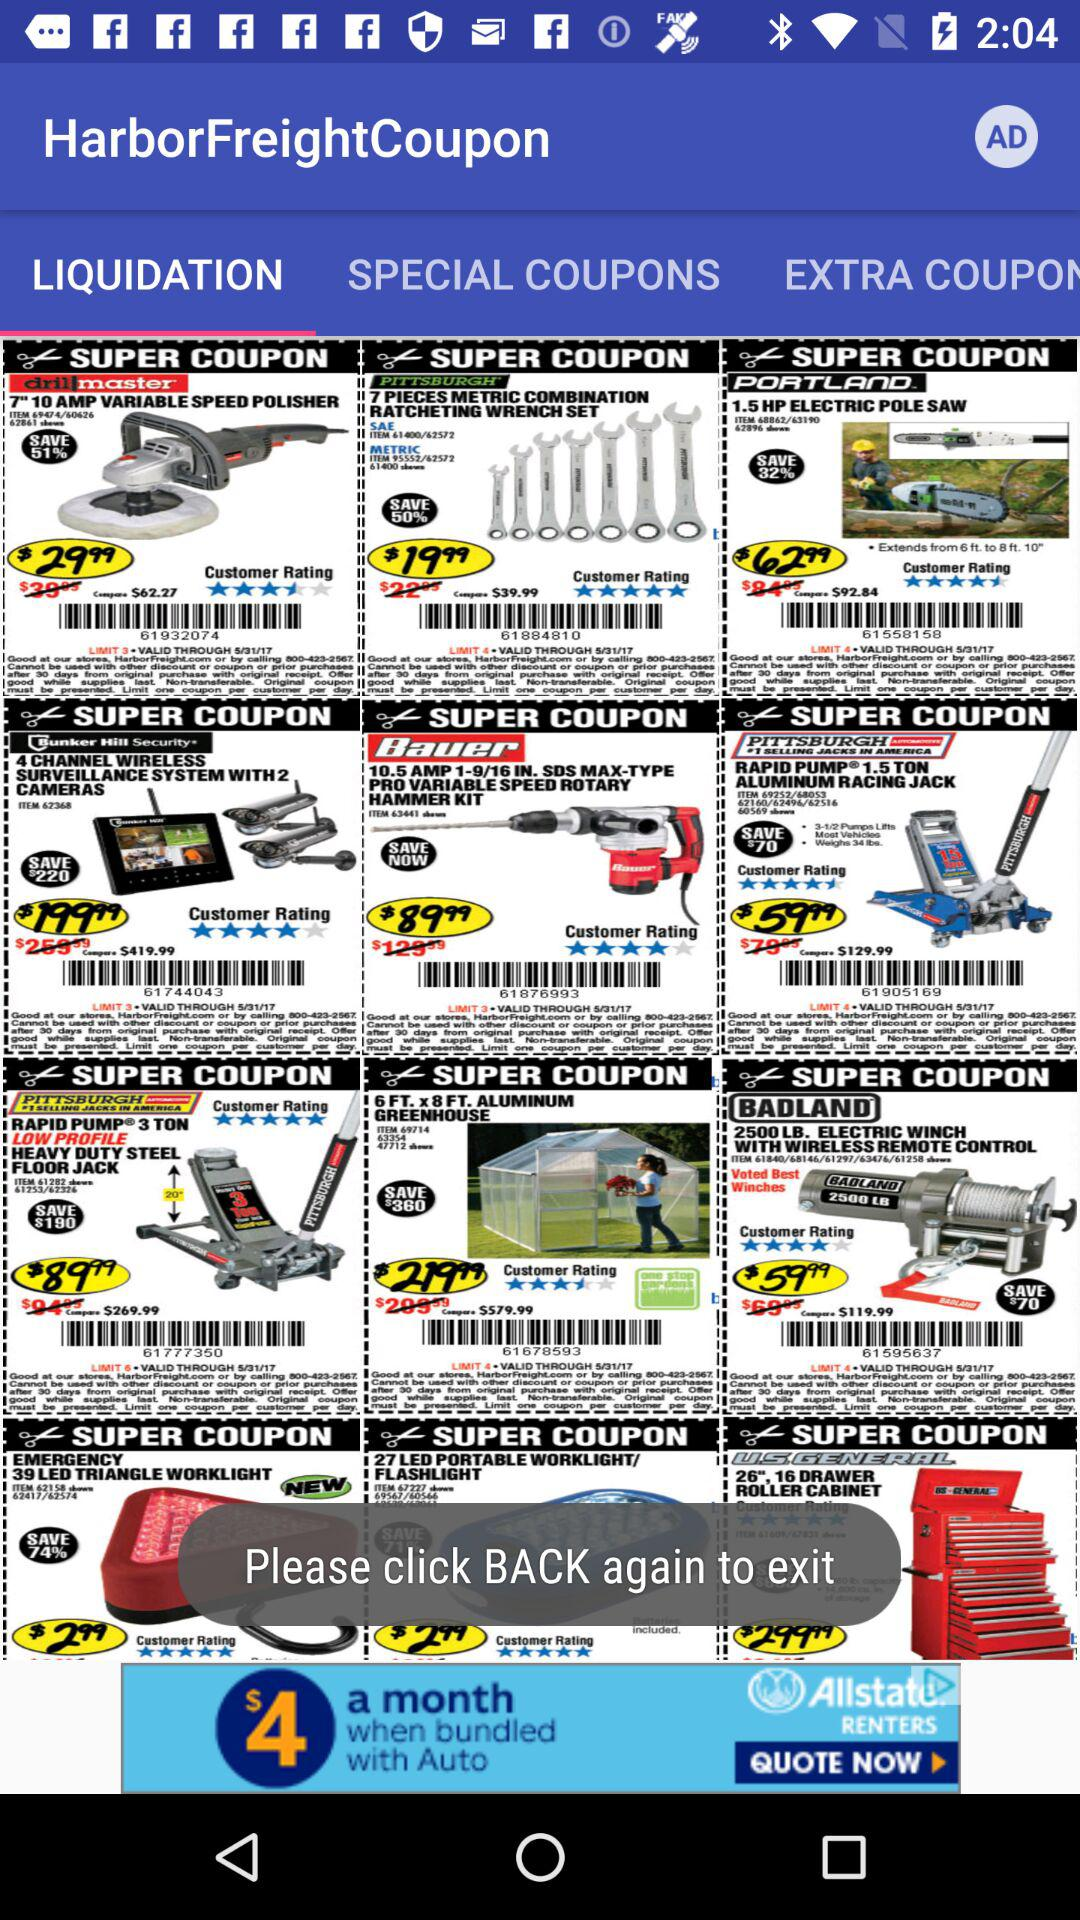What is the application name? The application name is "HarborFreightCoupon". 